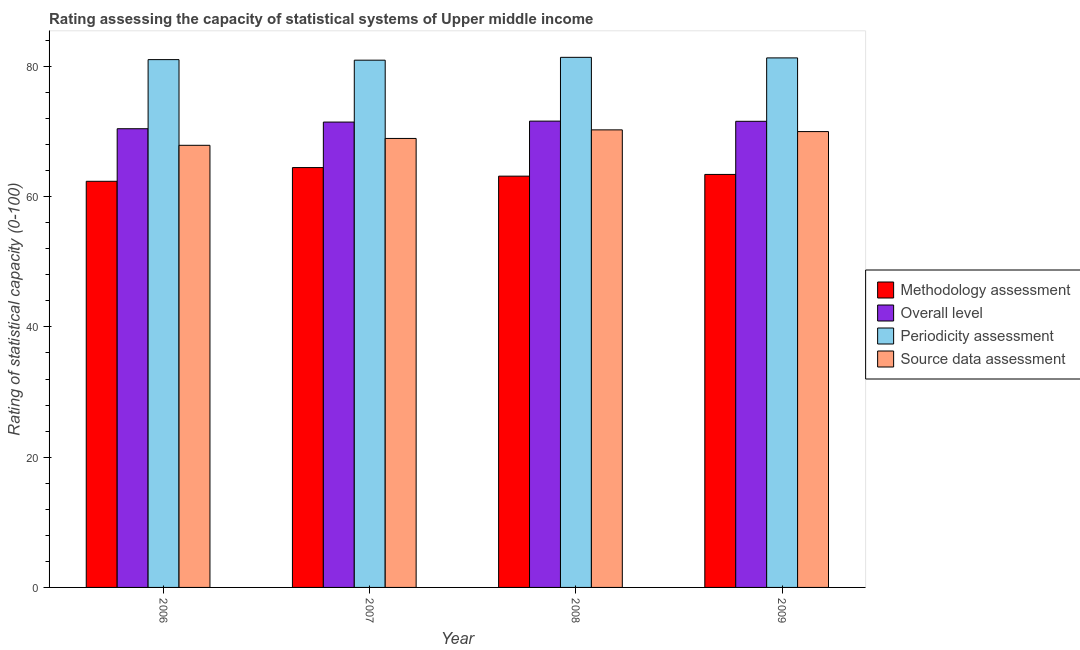How many groups of bars are there?
Offer a terse response. 4. Are the number of bars per tick equal to the number of legend labels?
Keep it short and to the point. Yes. What is the methodology assessment rating in 2007?
Your answer should be very brief. 64.47. Across all years, what is the maximum source data assessment rating?
Your answer should be compact. 70.26. Across all years, what is the minimum source data assessment rating?
Make the answer very short. 67.89. In which year was the overall level rating maximum?
Keep it short and to the point. 2008. In which year was the source data assessment rating minimum?
Provide a short and direct response. 2006. What is the total periodicity assessment rating in the graph?
Your answer should be compact. 324.74. What is the difference between the overall level rating in 2008 and that in 2009?
Provide a short and direct response. 0.03. What is the difference between the periodicity assessment rating in 2008 and the methodology assessment rating in 2009?
Give a very brief answer. 0.09. What is the average periodicity assessment rating per year?
Your answer should be compact. 81.18. In the year 2007, what is the difference between the methodology assessment rating and source data assessment rating?
Offer a terse response. 0. In how many years, is the periodicity assessment rating greater than 28?
Keep it short and to the point. 4. What is the ratio of the overall level rating in 2006 to that in 2008?
Your answer should be very brief. 0.98. Is the methodology assessment rating in 2007 less than that in 2008?
Offer a very short reply. No. What is the difference between the highest and the second highest periodicity assessment rating?
Offer a very short reply. 0.09. What is the difference between the highest and the lowest source data assessment rating?
Your answer should be very brief. 2.37. In how many years, is the source data assessment rating greater than the average source data assessment rating taken over all years?
Provide a short and direct response. 2. Is the sum of the source data assessment rating in 2006 and 2009 greater than the maximum methodology assessment rating across all years?
Offer a terse response. Yes. What does the 3rd bar from the left in 2008 represents?
Your response must be concise. Periodicity assessment. What does the 4th bar from the right in 2007 represents?
Make the answer very short. Methodology assessment. Is it the case that in every year, the sum of the methodology assessment rating and overall level rating is greater than the periodicity assessment rating?
Provide a short and direct response. Yes. How many years are there in the graph?
Provide a succinct answer. 4. What is the difference between two consecutive major ticks on the Y-axis?
Offer a very short reply. 20. Does the graph contain grids?
Your answer should be compact. No. How many legend labels are there?
Provide a succinct answer. 4. How are the legend labels stacked?
Offer a terse response. Vertical. What is the title of the graph?
Give a very brief answer. Rating assessing the capacity of statistical systems of Upper middle income. What is the label or title of the X-axis?
Ensure brevity in your answer.  Year. What is the label or title of the Y-axis?
Ensure brevity in your answer.  Rating of statistical capacity (0-100). What is the Rating of statistical capacity (0-100) in Methodology assessment in 2006?
Keep it short and to the point. 62.37. What is the Rating of statistical capacity (0-100) in Overall level in 2006?
Give a very brief answer. 70.44. What is the Rating of statistical capacity (0-100) of Periodicity assessment in 2006?
Make the answer very short. 81.05. What is the Rating of statistical capacity (0-100) in Source data assessment in 2006?
Your response must be concise. 67.89. What is the Rating of statistical capacity (0-100) in Methodology assessment in 2007?
Your response must be concise. 64.47. What is the Rating of statistical capacity (0-100) in Overall level in 2007?
Offer a terse response. 71.46. What is the Rating of statistical capacity (0-100) in Periodicity assessment in 2007?
Make the answer very short. 80.96. What is the Rating of statistical capacity (0-100) of Source data assessment in 2007?
Provide a short and direct response. 68.95. What is the Rating of statistical capacity (0-100) in Methodology assessment in 2008?
Your answer should be very brief. 63.16. What is the Rating of statistical capacity (0-100) of Overall level in 2008?
Ensure brevity in your answer.  71.61. What is the Rating of statistical capacity (0-100) of Periodicity assessment in 2008?
Your answer should be compact. 81.4. What is the Rating of statistical capacity (0-100) of Source data assessment in 2008?
Your response must be concise. 70.26. What is the Rating of statistical capacity (0-100) of Methodology assessment in 2009?
Make the answer very short. 63.42. What is the Rating of statistical capacity (0-100) of Overall level in 2009?
Your answer should be compact. 71.58. What is the Rating of statistical capacity (0-100) in Periodicity assessment in 2009?
Provide a succinct answer. 81.32. What is the Rating of statistical capacity (0-100) in Source data assessment in 2009?
Your response must be concise. 70. Across all years, what is the maximum Rating of statistical capacity (0-100) of Methodology assessment?
Keep it short and to the point. 64.47. Across all years, what is the maximum Rating of statistical capacity (0-100) in Overall level?
Give a very brief answer. 71.61. Across all years, what is the maximum Rating of statistical capacity (0-100) of Periodicity assessment?
Provide a succinct answer. 81.4. Across all years, what is the maximum Rating of statistical capacity (0-100) in Source data assessment?
Provide a short and direct response. 70.26. Across all years, what is the minimum Rating of statistical capacity (0-100) of Methodology assessment?
Offer a terse response. 62.37. Across all years, what is the minimum Rating of statistical capacity (0-100) of Overall level?
Give a very brief answer. 70.44. Across all years, what is the minimum Rating of statistical capacity (0-100) of Periodicity assessment?
Give a very brief answer. 80.96. Across all years, what is the minimum Rating of statistical capacity (0-100) in Source data assessment?
Your answer should be very brief. 67.89. What is the total Rating of statistical capacity (0-100) in Methodology assessment in the graph?
Give a very brief answer. 253.42. What is the total Rating of statistical capacity (0-100) of Overall level in the graph?
Give a very brief answer. 285.09. What is the total Rating of statistical capacity (0-100) of Periodicity assessment in the graph?
Your answer should be very brief. 324.74. What is the total Rating of statistical capacity (0-100) of Source data assessment in the graph?
Provide a short and direct response. 277.11. What is the difference between the Rating of statistical capacity (0-100) of Methodology assessment in 2006 and that in 2007?
Give a very brief answer. -2.11. What is the difference between the Rating of statistical capacity (0-100) in Overall level in 2006 and that in 2007?
Ensure brevity in your answer.  -1.02. What is the difference between the Rating of statistical capacity (0-100) of Periodicity assessment in 2006 and that in 2007?
Provide a short and direct response. 0.09. What is the difference between the Rating of statistical capacity (0-100) of Source data assessment in 2006 and that in 2007?
Provide a short and direct response. -1.05. What is the difference between the Rating of statistical capacity (0-100) of Methodology assessment in 2006 and that in 2008?
Offer a very short reply. -0.79. What is the difference between the Rating of statistical capacity (0-100) in Overall level in 2006 and that in 2008?
Offer a very short reply. -1.17. What is the difference between the Rating of statistical capacity (0-100) in Periodicity assessment in 2006 and that in 2008?
Provide a succinct answer. -0.35. What is the difference between the Rating of statistical capacity (0-100) of Source data assessment in 2006 and that in 2008?
Your response must be concise. -2.37. What is the difference between the Rating of statistical capacity (0-100) in Methodology assessment in 2006 and that in 2009?
Provide a short and direct response. -1.05. What is the difference between the Rating of statistical capacity (0-100) of Overall level in 2006 and that in 2009?
Provide a short and direct response. -1.14. What is the difference between the Rating of statistical capacity (0-100) of Periodicity assessment in 2006 and that in 2009?
Provide a short and direct response. -0.26. What is the difference between the Rating of statistical capacity (0-100) of Source data assessment in 2006 and that in 2009?
Provide a short and direct response. -2.11. What is the difference between the Rating of statistical capacity (0-100) in Methodology assessment in 2007 and that in 2008?
Your response must be concise. 1.32. What is the difference between the Rating of statistical capacity (0-100) in Overall level in 2007 and that in 2008?
Provide a short and direct response. -0.15. What is the difference between the Rating of statistical capacity (0-100) in Periodicity assessment in 2007 and that in 2008?
Your response must be concise. -0.44. What is the difference between the Rating of statistical capacity (0-100) of Source data assessment in 2007 and that in 2008?
Provide a succinct answer. -1.32. What is the difference between the Rating of statistical capacity (0-100) in Methodology assessment in 2007 and that in 2009?
Keep it short and to the point. 1.05. What is the difference between the Rating of statistical capacity (0-100) of Overall level in 2007 and that in 2009?
Your answer should be compact. -0.12. What is the difference between the Rating of statistical capacity (0-100) of Periodicity assessment in 2007 and that in 2009?
Make the answer very short. -0.35. What is the difference between the Rating of statistical capacity (0-100) of Source data assessment in 2007 and that in 2009?
Ensure brevity in your answer.  -1.05. What is the difference between the Rating of statistical capacity (0-100) in Methodology assessment in 2008 and that in 2009?
Offer a very short reply. -0.26. What is the difference between the Rating of statistical capacity (0-100) in Overall level in 2008 and that in 2009?
Keep it short and to the point. 0.03. What is the difference between the Rating of statistical capacity (0-100) in Periodicity assessment in 2008 and that in 2009?
Your answer should be compact. 0.09. What is the difference between the Rating of statistical capacity (0-100) of Source data assessment in 2008 and that in 2009?
Your response must be concise. 0.26. What is the difference between the Rating of statistical capacity (0-100) of Methodology assessment in 2006 and the Rating of statistical capacity (0-100) of Overall level in 2007?
Give a very brief answer. -9.09. What is the difference between the Rating of statistical capacity (0-100) in Methodology assessment in 2006 and the Rating of statistical capacity (0-100) in Periodicity assessment in 2007?
Give a very brief answer. -18.6. What is the difference between the Rating of statistical capacity (0-100) of Methodology assessment in 2006 and the Rating of statistical capacity (0-100) of Source data assessment in 2007?
Give a very brief answer. -6.58. What is the difference between the Rating of statistical capacity (0-100) of Overall level in 2006 and the Rating of statistical capacity (0-100) of Periodicity assessment in 2007?
Ensure brevity in your answer.  -10.53. What is the difference between the Rating of statistical capacity (0-100) of Overall level in 2006 and the Rating of statistical capacity (0-100) of Source data assessment in 2007?
Make the answer very short. 1.49. What is the difference between the Rating of statistical capacity (0-100) in Periodicity assessment in 2006 and the Rating of statistical capacity (0-100) in Source data assessment in 2007?
Make the answer very short. 12.11. What is the difference between the Rating of statistical capacity (0-100) of Methodology assessment in 2006 and the Rating of statistical capacity (0-100) of Overall level in 2008?
Ensure brevity in your answer.  -9.24. What is the difference between the Rating of statistical capacity (0-100) in Methodology assessment in 2006 and the Rating of statistical capacity (0-100) in Periodicity assessment in 2008?
Your answer should be very brief. -19.03. What is the difference between the Rating of statistical capacity (0-100) in Methodology assessment in 2006 and the Rating of statistical capacity (0-100) in Source data assessment in 2008?
Provide a short and direct response. -7.89. What is the difference between the Rating of statistical capacity (0-100) of Overall level in 2006 and the Rating of statistical capacity (0-100) of Periodicity assessment in 2008?
Keep it short and to the point. -10.96. What is the difference between the Rating of statistical capacity (0-100) of Overall level in 2006 and the Rating of statistical capacity (0-100) of Source data assessment in 2008?
Your answer should be compact. 0.18. What is the difference between the Rating of statistical capacity (0-100) of Periodicity assessment in 2006 and the Rating of statistical capacity (0-100) of Source data assessment in 2008?
Provide a succinct answer. 10.79. What is the difference between the Rating of statistical capacity (0-100) of Methodology assessment in 2006 and the Rating of statistical capacity (0-100) of Overall level in 2009?
Your answer should be very brief. -9.21. What is the difference between the Rating of statistical capacity (0-100) of Methodology assessment in 2006 and the Rating of statistical capacity (0-100) of Periodicity assessment in 2009?
Provide a short and direct response. -18.95. What is the difference between the Rating of statistical capacity (0-100) of Methodology assessment in 2006 and the Rating of statistical capacity (0-100) of Source data assessment in 2009?
Keep it short and to the point. -7.63. What is the difference between the Rating of statistical capacity (0-100) in Overall level in 2006 and the Rating of statistical capacity (0-100) in Periodicity assessment in 2009?
Keep it short and to the point. -10.88. What is the difference between the Rating of statistical capacity (0-100) in Overall level in 2006 and the Rating of statistical capacity (0-100) in Source data assessment in 2009?
Make the answer very short. 0.44. What is the difference between the Rating of statistical capacity (0-100) in Periodicity assessment in 2006 and the Rating of statistical capacity (0-100) in Source data assessment in 2009?
Provide a short and direct response. 11.05. What is the difference between the Rating of statistical capacity (0-100) of Methodology assessment in 2007 and the Rating of statistical capacity (0-100) of Overall level in 2008?
Provide a short and direct response. -7.13. What is the difference between the Rating of statistical capacity (0-100) in Methodology assessment in 2007 and the Rating of statistical capacity (0-100) in Periodicity assessment in 2008?
Make the answer very short. -16.93. What is the difference between the Rating of statistical capacity (0-100) of Methodology assessment in 2007 and the Rating of statistical capacity (0-100) of Source data assessment in 2008?
Give a very brief answer. -5.79. What is the difference between the Rating of statistical capacity (0-100) in Overall level in 2007 and the Rating of statistical capacity (0-100) in Periodicity assessment in 2008?
Make the answer very short. -9.94. What is the difference between the Rating of statistical capacity (0-100) of Overall level in 2007 and the Rating of statistical capacity (0-100) of Source data assessment in 2008?
Your response must be concise. 1.2. What is the difference between the Rating of statistical capacity (0-100) in Periodicity assessment in 2007 and the Rating of statistical capacity (0-100) in Source data assessment in 2008?
Provide a short and direct response. 10.7. What is the difference between the Rating of statistical capacity (0-100) in Methodology assessment in 2007 and the Rating of statistical capacity (0-100) in Overall level in 2009?
Provide a short and direct response. -7.11. What is the difference between the Rating of statistical capacity (0-100) of Methodology assessment in 2007 and the Rating of statistical capacity (0-100) of Periodicity assessment in 2009?
Your answer should be very brief. -16.84. What is the difference between the Rating of statistical capacity (0-100) of Methodology assessment in 2007 and the Rating of statistical capacity (0-100) of Source data assessment in 2009?
Your answer should be compact. -5.53. What is the difference between the Rating of statistical capacity (0-100) of Overall level in 2007 and the Rating of statistical capacity (0-100) of Periodicity assessment in 2009?
Your response must be concise. -9.85. What is the difference between the Rating of statistical capacity (0-100) of Overall level in 2007 and the Rating of statistical capacity (0-100) of Source data assessment in 2009?
Make the answer very short. 1.46. What is the difference between the Rating of statistical capacity (0-100) of Periodicity assessment in 2007 and the Rating of statistical capacity (0-100) of Source data assessment in 2009?
Your answer should be very brief. 10.96. What is the difference between the Rating of statistical capacity (0-100) of Methodology assessment in 2008 and the Rating of statistical capacity (0-100) of Overall level in 2009?
Offer a terse response. -8.42. What is the difference between the Rating of statistical capacity (0-100) in Methodology assessment in 2008 and the Rating of statistical capacity (0-100) in Periodicity assessment in 2009?
Your response must be concise. -18.16. What is the difference between the Rating of statistical capacity (0-100) of Methodology assessment in 2008 and the Rating of statistical capacity (0-100) of Source data assessment in 2009?
Your answer should be very brief. -6.84. What is the difference between the Rating of statistical capacity (0-100) of Overall level in 2008 and the Rating of statistical capacity (0-100) of Periodicity assessment in 2009?
Give a very brief answer. -9.71. What is the difference between the Rating of statistical capacity (0-100) in Overall level in 2008 and the Rating of statistical capacity (0-100) in Source data assessment in 2009?
Your answer should be compact. 1.61. What is the difference between the Rating of statistical capacity (0-100) of Periodicity assessment in 2008 and the Rating of statistical capacity (0-100) of Source data assessment in 2009?
Provide a short and direct response. 11.4. What is the average Rating of statistical capacity (0-100) of Methodology assessment per year?
Provide a succinct answer. 63.36. What is the average Rating of statistical capacity (0-100) of Overall level per year?
Provide a succinct answer. 71.27. What is the average Rating of statistical capacity (0-100) in Periodicity assessment per year?
Offer a terse response. 81.18. What is the average Rating of statistical capacity (0-100) in Source data assessment per year?
Your response must be concise. 69.28. In the year 2006, what is the difference between the Rating of statistical capacity (0-100) of Methodology assessment and Rating of statistical capacity (0-100) of Overall level?
Make the answer very short. -8.07. In the year 2006, what is the difference between the Rating of statistical capacity (0-100) in Methodology assessment and Rating of statistical capacity (0-100) in Periodicity assessment?
Provide a succinct answer. -18.68. In the year 2006, what is the difference between the Rating of statistical capacity (0-100) of Methodology assessment and Rating of statistical capacity (0-100) of Source data assessment?
Your answer should be very brief. -5.53. In the year 2006, what is the difference between the Rating of statistical capacity (0-100) of Overall level and Rating of statistical capacity (0-100) of Periodicity assessment?
Offer a very short reply. -10.61. In the year 2006, what is the difference between the Rating of statistical capacity (0-100) in Overall level and Rating of statistical capacity (0-100) in Source data assessment?
Your answer should be compact. 2.54. In the year 2006, what is the difference between the Rating of statistical capacity (0-100) in Periodicity assessment and Rating of statistical capacity (0-100) in Source data assessment?
Your response must be concise. 13.16. In the year 2007, what is the difference between the Rating of statistical capacity (0-100) in Methodology assessment and Rating of statistical capacity (0-100) in Overall level?
Ensure brevity in your answer.  -6.99. In the year 2007, what is the difference between the Rating of statistical capacity (0-100) of Methodology assessment and Rating of statistical capacity (0-100) of Periodicity assessment?
Provide a succinct answer. -16.49. In the year 2007, what is the difference between the Rating of statistical capacity (0-100) of Methodology assessment and Rating of statistical capacity (0-100) of Source data assessment?
Your answer should be compact. -4.47. In the year 2007, what is the difference between the Rating of statistical capacity (0-100) in Overall level and Rating of statistical capacity (0-100) in Periodicity assessment?
Provide a short and direct response. -9.5. In the year 2007, what is the difference between the Rating of statistical capacity (0-100) of Overall level and Rating of statistical capacity (0-100) of Source data assessment?
Make the answer very short. 2.51. In the year 2007, what is the difference between the Rating of statistical capacity (0-100) in Periodicity assessment and Rating of statistical capacity (0-100) in Source data assessment?
Offer a terse response. 12.02. In the year 2008, what is the difference between the Rating of statistical capacity (0-100) in Methodology assessment and Rating of statistical capacity (0-100) in Overall level?
Offer a very short reply. -8.45. In the year 2008, what is the difference between the Rating of statistical capacity (0-100) in Methodology assessment and Rating of statistical capacity (0-100) in Periodicity assessment?
Give a very brief answer. -18.25. In the year 2008, what is the difference between the Rating of statistical capacity (0-100) in Methodology assessment and Rating of statistical capacity (0-100) in Source data assessment?
Your answer should be very brief. -7.11. In the year 2008, what is the difference between the Rating of statistical capacity (0-100) in Overall level and Rating of statistical capacity (0-100) in Periodicity assessment?
Provide a succinct answer. -9.8. In the year 2008, what is the difference between the Rating of statistical capacity (0-100) of Overall level and Rating of statistical capacity (0-100) of Source data assessment?
Your response must be concise. 1.34. In the year 2008, what is the difference between the Rating of statistical capacity (0-100) in Periodicity assessment and Rating of statistical capacity (0-100) in Source data assessment?
Your response must be concise. 11.14. In the year 2009, what is the difference between the Rating of statistical capacity (0-100) in Methodology assessment and Rating of statistical capacity (0-100) in Overall level?
Provide a succinct answer. -8.16. In the year 2009, what is the difference between the Rating of statistical capacity (0-100) in Methodology assessment and Rating of statistical capacity (0-100) in Periodicity assessment?
Provide a succinct answer. -17.89. In the year 2009, what is the difference between the Rating of statistical capacity (0-100) in Methodology assessment and Rating of statistical capacity (0-100) in Source data assessment?
Offer a terse response. -6.58. In the year 2009, what is the difference between the Rating of statistical capacity (0-100) of Overall level and Rating of statistical capacity (0-100) of Periodicity assessment?
Make the answer very short. -9.74. In the year 2009, what is the difference between the Rating of statistical capacity (0-100) of Overall level and Rating of statistical capacity (0-100) of Source data assessment?
Your answer should be compact. 1.58. In the year 2009, what is the difference between the Rating of statistical capacity (0-100) of Periodicity assessment and Rating of statistical capacity (0-100) of Source data assessment?
Provide a short and direct response. 11.32. What is the ratio of the Rating of statistical capacity (0-100) in Methodology assessment in 2006 to that in 2007?
Provide a succinct answer. 0.97. What is the ratio of the Rating of statistical capacity (0-100) of Overall level in 2006 to that in 2007?
Offer a terse response. 0.99. What is the ratio of the Rating of statistical capacity (0-100) of Source data assessment in 2006 to that in 2007?
Provide a short and direct response. 0.98. What is the ratio of the Rating of statistical capacity (0-100) in Methodology assessment in 2006 to that in 2008?
Your answer should be very brief. 0.99. What is the ratio of the Rating of statistical capacity (0-100) of Overall level in 2006 to that in 2008?
Ensure brevity in your answer.  0.98. What is the ratio of the Rating of statistical capacity (0-100) of Periodicity assessment in 2006 to that in 2008?
Offer a very short reply. 1. What is the ratio of the Rating of statistical capacity (0-100) of Source data assessment in 2006 to that in 2008?
Make the answer very short. 0.97. What is the ratio of the Rating of statistical capacity (0-100) in Methodology assessment in 2006 to that in 2009?
Provide a succinct answer. 0.98. What is the ratio of the Rating of statistical capacity (0-100) in Overall level in 2006 to that in 2009?
Your answer should be very brief. 0.98. What is the ratio of the Rating of statistical capacity (0-100) in Source data assessment in 2006 to that in 2009?
Ensure brevity in your answer.  0.97. What is the ratio of the Rating of statistical capacity (0-100) in Methodology assessment in 2007 to that in 2008?
Give a very brief answer. 1.02. What is the ratio of the Rating of statistical capacity (0-100) in Source data assessment in 2007 to that in 2008?
Make the answer very short. 0.98. What is the ratio of the Rating of statistical capacity (0-100) of Methodology assessment in 2007 to that in 2009?
Ensure brevity in your answer.  1.02. What is the ratio of the Rating of statistical capacity (0-100) of Overall level in 2007 to that in 2009?
Provide a short and direct response. 1. What is the ratio of the Rating of statistical capacity (0-100) of Periodicity assessment in 2007 to that in 2009?
Your answer should be very brief. 1. What is the difference between the highest and the second highest Rating of statistical capacity (0-100) of Methodology assessment?
Offer a terse response. 1.05. What is the difference between the highest and the second highest Rating of statistical capacity (0-100) in Overall level?
Your response must be concise. 0.03. What is the difference between the highest and the second highest Rating of statistical capacity (0-100) of Periodicity assessment?
Make the answer very short. 0.09. What is the difference between the highest and the second highest Rating of statistical capacity (0-100) in Source data assessment?
Provide a succinct answer. 0.26. What is the difference between the highest and the lowest Rating of statistical capacity (0-100) of Methodology assessment?
Your answer should be very brief. 2.11. What is the difference between the highest and the lowest Rating of statistical capacity (0-100) in Overall level?
Your response must be concise. 1.17. What is the difference between the highest and the lowest Rating of statistical capacity (0-100) in Periodicity assessment?
Offer a very short reply. 0.44. What is the difference between the highest and the lowest Rating of statistical capacity (0-100) in Source data assessment?
Provide a short and direct response. 2.37. 